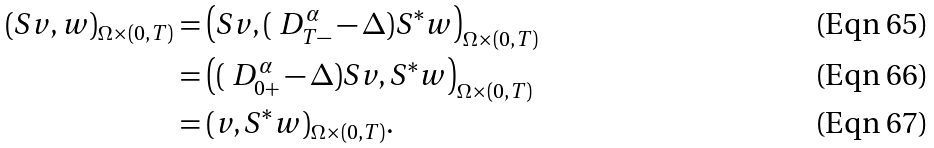<formula> <loc_0><loc_0><loc_500><loc_500>( S v , w ) _ { \Omega \times ( 0 , T ) } & = \left ( S v , ( \ D _ { T - } ^ { \alpha } - \Delta ) S ^ { * } w \right ) _ { \Omega \times ( 0 , T ) } \\ & = \left ( ( \ D _ { 0 + } ^ { \alpha } - \Delta ) S v , S ^ { * } w \right ) _ { \Omega \times ( 0 , T ) } \\ & = ( v , S ^ { * } w ) _ { \Omega \times ( 0 , T ) } .</formula> 